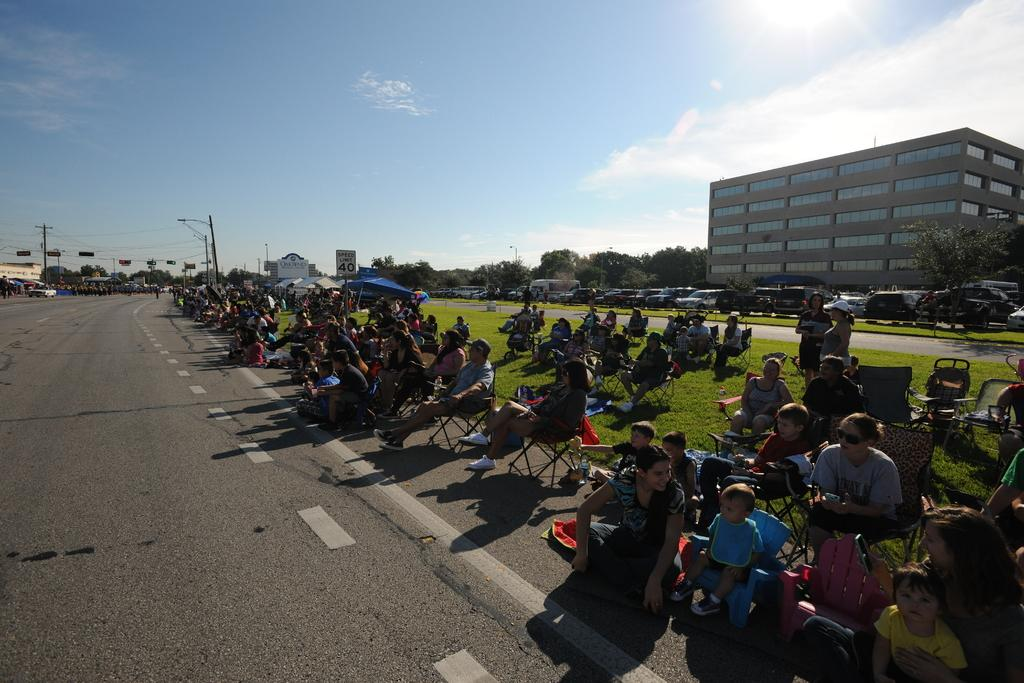What are the people in the image doing? The people in the image are sitting on chairs. What type of vehicles can be seen in the image? There are cars in the image. What type of lighting is present in the image? There are street lamps in the image. What type of vegetation is present in the image? There are trees in the image. What type of structures are present in the image? There are buildings in the image. What is visible at the top of the image? The sky is visible at the top of the image. How many snails can be seen crawling on the floor in the image? There are no snails visible crawling on the floor in the image. 